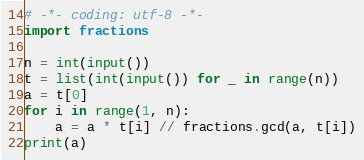Convert code to text. <code><loc_0><loc_0><loc_500><loc_500><_Python_># -*- coding: utf-8 -*-
import fractions

n = int(input())
t = list(int(input()) for _ in range(n))
a = t[0]
for i in range(1, n):
    a = a * t[i] // fractions.gcd(a, t[i])
print(a)
</code> 